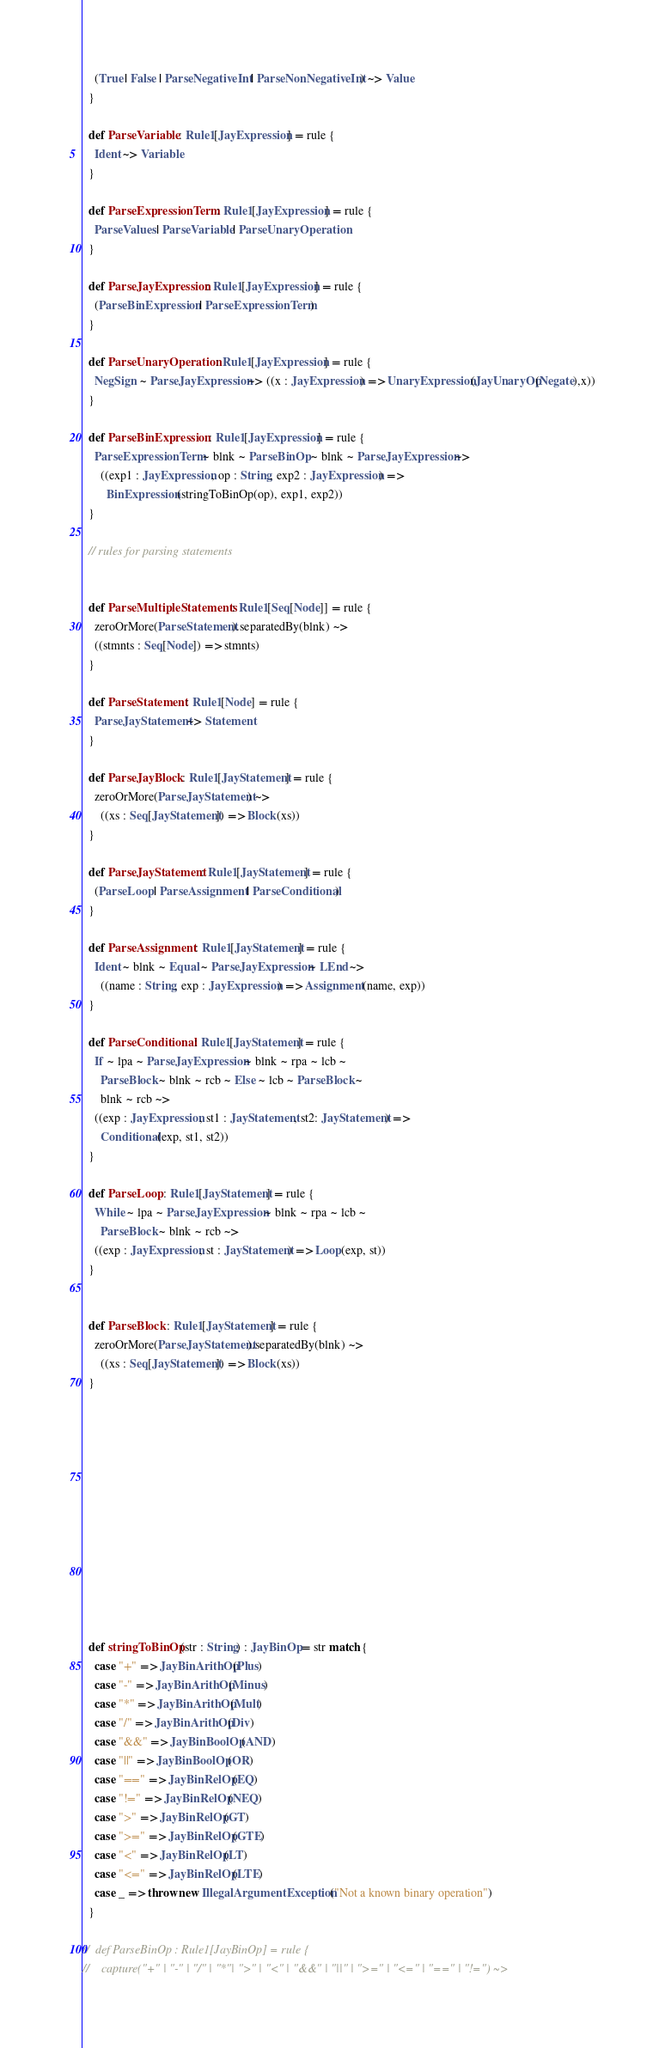<code> <loc_0><loc_0><loc_500><loc_500><_Scala_>    (True | False | ParseNegativeInt | ParseNonNegativeInt) ~> Value
  }

  def ParseVariable : Rule1[JayExpression] = rule {
    Ident ~> Variable
  }

  def ParseExpressionTerm : Rule1[JayExpression] = rule {
    ParseValues | ParseVariable | ParseUnaryOperation
  }
  
  def ParseJayExpression : Rule1[JayExpression] = rule {
    (ParseBinExpression | ParseExpressionTerm)
  }

  def ParseUnaryOperation : Rule1[JayExpression] = rule {
    NegSign ~ ParseJayExpression ~> ((x : JayExpression) => UnaryExpression(JayUnaryOp(Negate),x))
  }

  def ParseBinExpression : Rule1[JayExpression] = rule {
    ParseExpressionTerm ~ blnk ~ ParseBinOp ~ blnk ~ ParseJayExpression ~> 
      ((exp1 : JayExpression, op : String, exp2 : JayExpression) => 
        BinExpression(stringToBinOp(op), exp1, exp2))
  }
  
  // rules for parsing statements
  
  
  def ParseMultipleStatements : Rule1[Seq[Node]] = rule {
    zeroOrMore(ParseStatement).separatedBy(blnk) ~>
    ((stmnts : Seq[Node]) => stmnts)
  }
  
  def ParseStatement : Rule1[Node] = rule {
    ParseJayStatement ~> Statement
  }
  
  def ParseJayBlock : Rule1[JayStatement] = rule {
    zeroOrMore(ParseJayStatement) ~> 
      ((xs : Seq[JayStatement]) => Block(xs))
  }
  
  def ParseJayStatement : Rule1[JayStatement] = rule {
    (ParseLoop | ParseAssignment | ParseConditional)
  }
  
  def ParseAssignment : Rule1[JayStatement] = rule {
    Ident ~ blnk ~ Equal ~ ParseJayExpression ~ LEnd ~> 
      ((name : String, exp : JayExpression) => Assignment(name, exp))
  }
  
  def ParseConditional : Rule1[JayStatement] = rule {
    If ~ lpa ~ ParseJayExpression ~ blnk ~ rpa ~ lcb ~
      ParseBlock ~ blnk ~ rcb ~ Else ~ lcb ~ ParseBlock ~
      blnk ~ rcb ~> 
    ((exp : JayExpression, st1 : JayStatement, st2: JayStatement) =>
      Conditional(exp, st1, st2))
  }
  
  def ParseLoop : Rule1[JayStatement] = rule {
    While ~ lpa ~ ParseJayExpression ~ blnk ~ rpa ~ lcb ~
      ParseBlock ~ blnk ~ rcb ~> 
    ((exp : JayExpression, st : JayStatement) => Loop(exp, st))
  }
  
  
  def ParseBlock : Rule1[JayStatement] = rule {
    zeroOrMore(ParseJayStatement).separatedBy(blnk) ~>
      ((xs : Seq[JayStatement]) => Block(xs))
  }
  
 











  def stringToBinOp(str : String) : JayBinOp = str match {
    case "+" => JayBinArithOp(Plus)
    case "-" => JayBinArithOp(Minus)
    case "*" => JayBinArithOp(Mult)
    case "/" => JayBinArithOp(Div)
    case "&&" => JayBinBoolOp(AND)
    case "||" => JayBinBoolOp(OR)
    case "==" => JayBinRelOp(EQ)
    case "!=" => JayBinRelOp(NEQ)
    case ">" => JayBinRelOp(GT)
    case ">=" => JayBinRelOp(GTE)
    case "<" => JayBinRelOp(LT)
    case "<=" => JayBinRelOp(LTE)
    case _ => throw new IllegalArgumentException("Not a known binary operation")
  }

//  def ParseBinOp : Rule1[JayBinOp] = rule {
//    capture("+" | "-" | "/" | "*"| ">" | "<" | "&&" | "||" | ">=" | "<=" | "==" | "!=") ~></code> 